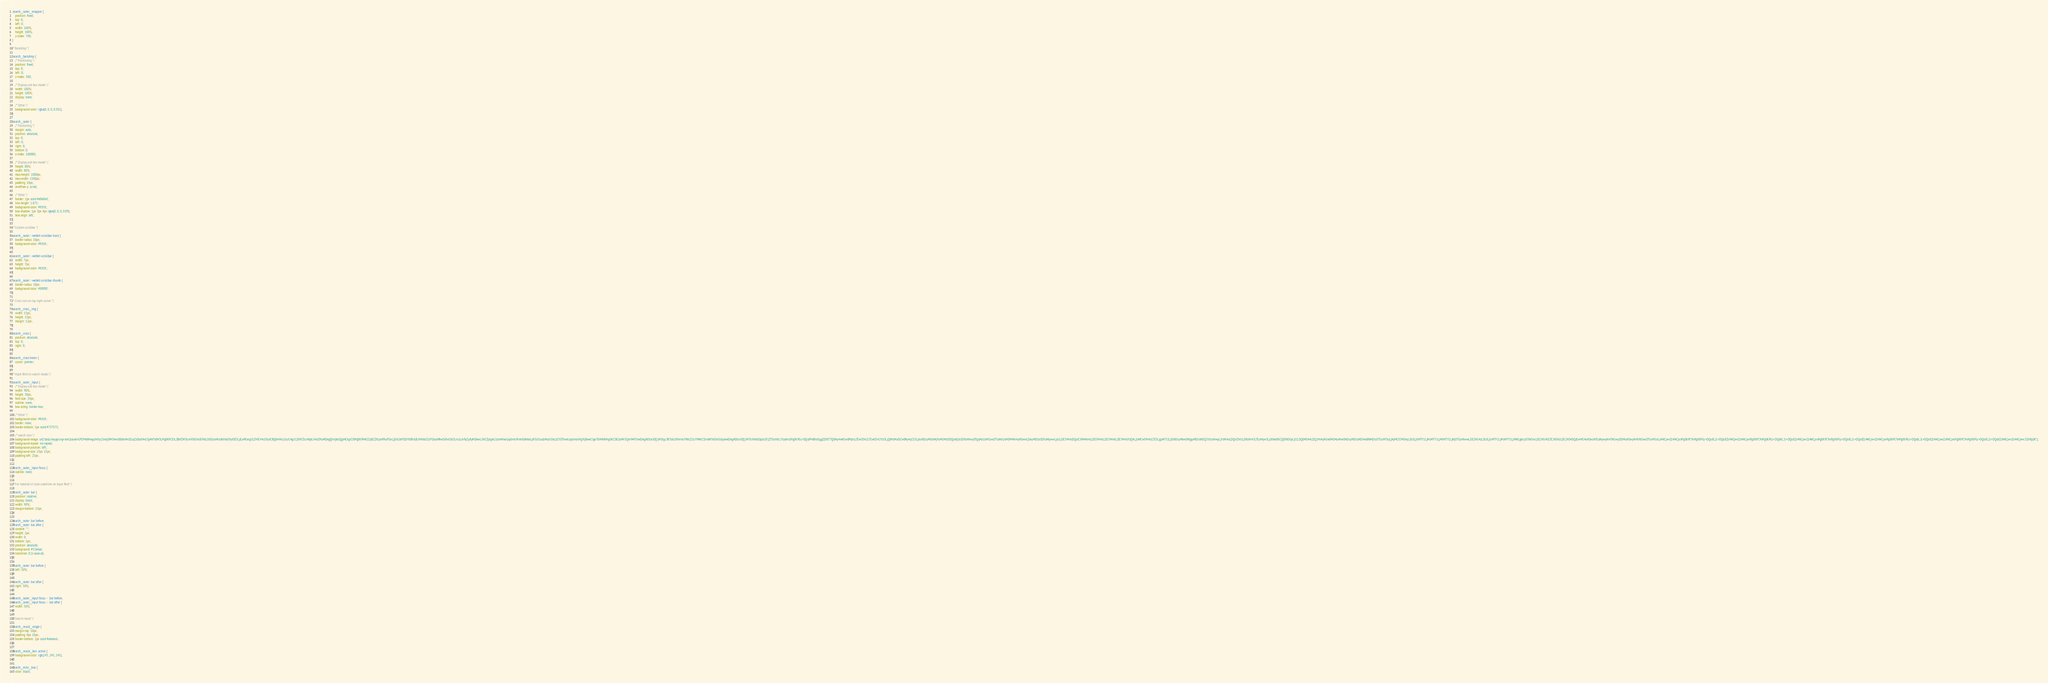Convert code to text. <code><loc_0><loc_0><loc_500><loc_500><_CSS_>.search__outer__wrapper {
    position: fixed;
    top: 0;
    left: 0;
    width: 100%;
    height: 100%;
    z-index: 700;
}

/* Backdrop */

.search__backdrop {
    /* Positioning */
    position: fixed;
    top: 0;
    left: 0;
    z-index: 500;

    /* Display and box model */
    width: 100%;
    height: 100%;
    display: none;

    /* Other */
    background-color: rgba(0, 0, 0, 0.502);
}

.search__outer {
    /* Positioning */
    margin: auto;
    position: absolute;
    top: 0;
    left: 0;
    right: 0;
    bottom: 0;
    z-index: 100000;

    /* Display and box model */
    height: 80%;
    width: 80%;
    max-height: 1000px;
    max-width: 1500px;
    padding: 10px;
    overflow-y: scroll;

    /* Other */
    border: 1px solid #e0e0e0;
    line-height: 1.875;
    background-color: #fcfcfc;
    box-shadow: 1px 3px 4px rgba(0, 0, 0, 0.09);
    text-align: left;
}

/* Custom scrollbar */

.search__outer::-webkit-scrollbar-track {
    border-radius: 10px;
    background-color: #fcfcfc;
}

.search__outer::-webkit-scrollbar {
    width: 7px;
    height: 7px;
    background-color: #fcfcfc;
}

.search__outer::-webkit-scrollbar-thumb {
    border-radius: 10px;
    background-color: #8f8f8f;
}

/* Cross icon on top-right corner */

.search__cross__img {
    width: 15px;
    height: 15px;
    margin: 12px;
}

.search__cross {
    position: absolute;
    top: 0;
    right: 0;
}

.search__cross:hover {
    cursor: pointer;
}

/* Input field on search modal */

.search__outer__input {
    /* Display and box model */
    width: 90%;
    height: 30px;
    font-size: 19px;
    outline: none;
    box-sizing: border-box;

    /* Other */
    background-color: #fcfcfc;
    border: none;
    border-bottom: 1px solid #757575;

    /* search icon */
    background-image: url("data:image/svg+xml;base64,PD94bWwgdmVyc2lvbj0iMS4wIiBlbmNvZGluZz0iaXNvLTg4NTktMSI/Pg0KPCEtLSBHZW5lcmF0b3I6IEFkb2JlIElsbHVzdHJhdG9yIDE5LjEuMCwgU1ZHIEV4cG9ydCBQbHVnLUluIC4gU1ZHIFZlcnNpb246IDYuMDAgQnVpbGQgMCkgIC0tPg0KPHN2ZyB2ZXJzaW9uPSIxLjEiIGlkPSJDYXBhXzEiIHhtbG5zPSJodHRwOi8vd3d3LnczLm9yZy8yMDAwL3N2ZyIgeG1sbnM6eGxpbms9Imh0dHA6Ly93d3cudzMub3JnLzE5OTkveGxpbmsiIHg9IjBweCIgeT0iMHB4Ig0KCSB2aWV3Qm94PSIwIDAgNDUxIDQ1MSIgc3R5bGU9ImVuYWJsZS1iYWNrZ3JvdW5kOm5ldyAwIDAgNDUxIDQ1MTsiIHhtbDpzcGFjZT0icHJlc2VydmUiPg0KPGc+DQoJPHBhdGggZD0iTTQ0Ny4wNSw0MjhsLTEwOS42LTEwOS42YzI5LjQtMzMuOCw0Ny4yLTc3LjksNDcuMi0xMjYuMUMzODQuNjUsODYuMiwyOTguMzUsMCwxOTIuMzUsMEM4Ni4yNSwwLDAuMDUsODYuMywwLjA1LDE5Mi4zDQoJCXM4Ni4zLDE5Mi4zLDE5Mi4zLDE5Mi4zYzQ4LjIsMCw5Mi4zLTE3LjgsMTI2LjEtNDcuMkw0MjguMDUsNDQ3YzIuNiwyLjYsNi4xLDQsOS41LDRzNi45LTEuMyw5LjUtNA0KCQlDNDUyLjI1LDQ0MS44LDQ1Mi4yNSw0MzMuMiw0NDcuMDUsNDI4eiBNMjYuOTUsMTkyLjNjMC05MS4yLDc0LjItMTY1LjMsMTY1LjMtMTY1LjNjOTEuMiwwLDE2NS4zLDc0LjIsMTY1LjMsMTY1LjMNCgkJcy03NC4xLDE2NS40LTE2NS4zLDE2NS40QzEwMS4xNSwzNTcuNywyNi45NSwyODMuNSwyNi45NSwxOTIuM3oiLz4NCjwvZz4NCjxnPg0KPC9nPg0KPGc+DQo8L2c+DQo8Zz4NCjwvZz4NCjxnPg0KPC9nPg0KPGc+DQo8L2c+DQo8Zz4NCjwvZz4NCjxnPg0KPC9nPg0KPGc+DQo8L2c+DQo8Zz4NCjwvZz4NCjxnPg0KPC9nPg0KPGc+DQo8L2c+DQo8Zz4NCjwvZz4NCjxnPg0KPC9nPg0KPGc+DQo8L2c+DQo8Zz4NCjwvZz4NCjwvc3ZnPg0K");
    background-repeat: no-repeat;
    background-position: left;
    background-size: 15px 15px;
    padding-left: 25px;
}

.search__outer__input:focus {
    outline: none;
}

/* For material UI style underline on input field */

.search__outer .bar {
    position: relative;
    display: block;
    width: 90%;
    margin-bottom: 15px;
}

.search__outer .bar:before,
.search__outer .bar:after {
    content: "";
    height: 2px;
    width: 0;
    bottom: 1px;
    position: absolute;
    background: #5264ae;
    transition: 0.2s ease all;
}

.search__outer .bar:before {
    left: 50%;
}

.search__outer .bar:after {
    right: 50%;
}

.search__outer__input:focus ~ .bar:before,
.search__outer__input:focus ~ .bar:after {
    width: 50%;
}

/* Search result */

.search__result__single {
    margin-top: 10px;
    padding: 0px 10px;
    border-bottom: 1px solid #e6e6e6;
}

.search__result__box .active {
    background-color: rgb(245, 245, 245);
}

.search__error__box {
    color: black;</code> 